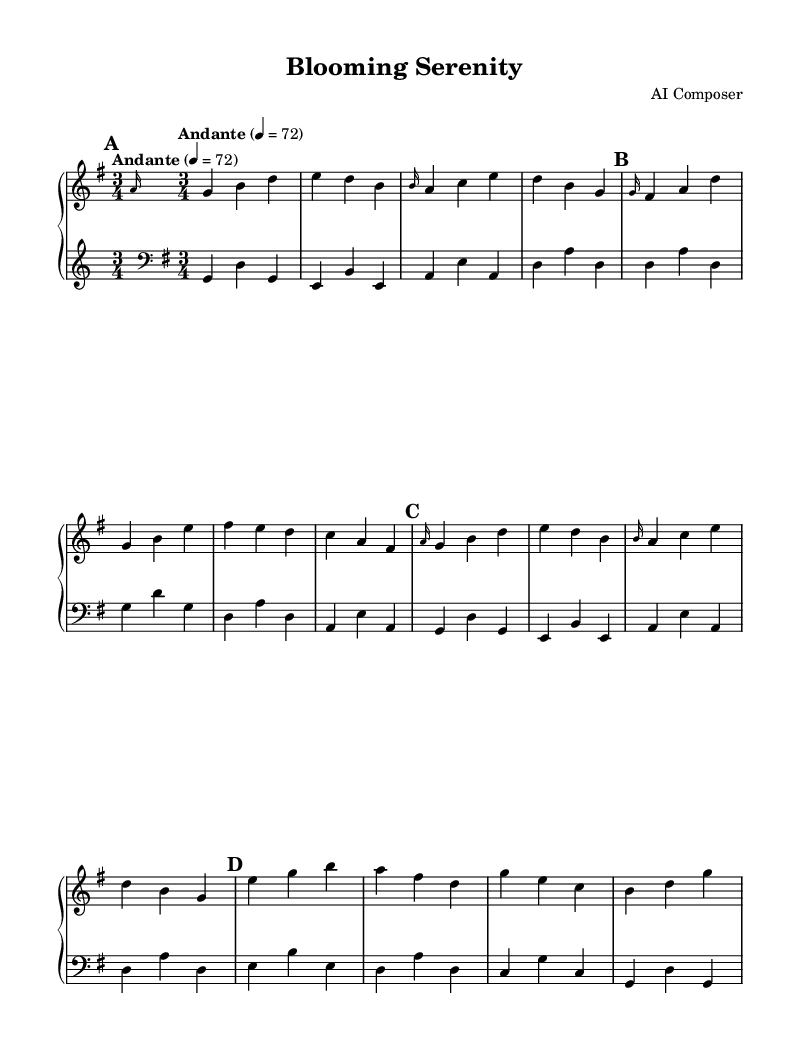What is the key signature of this music? The key signature is displayed on the staff at the beginning of the piece. Here, there is one sharp, indicating that the piece is in G major.
Answer: G major What is the time signature of this music? The time signature is located at the beginning of the piece, right after the key signature. It shows 3/4, meaning three beats per measure and a quarter note receives one beat.
Answer: 3/4 What is the tempo marking of this music? The tempo marking is found near the beginning of the score and states "Andante," which indicates a moderate pace or walking speed.
Answer: Andante How many sections are there in this composition? By analyzing the structure of the score, we see four distinct sections labeled A, B, A', and C. Each section has a different musical theme.
Answer: Four What is the range of the piano parts in this piece? By examining the highest and lowest notes in the upper and lower staves, we find that the upper part reaches a high of b and the lower part has a low of g. The span between them indicates a range of an octave.
Answer: Octave What is the overall mood conveyed by the piece? Analyzing the dynamics, tempo, and key signature, we can infer that the piece conveys a serene and tranquil atmosphere, reflective of a garden landscape. The gentle flowing lines and moderate tempo support this impression.
Answer: Serene 